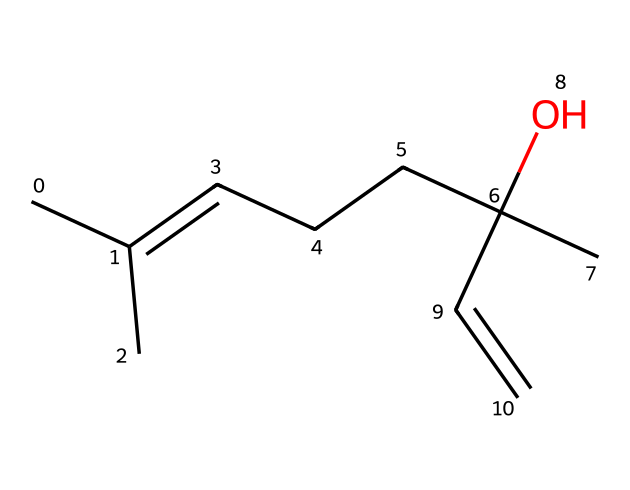What is the common name of this compound? This compound is identified as linalool, which is a well-known terpene commonly found in lavender. The structure reflects common identifying features of linalool.
Answer: linalool How many carbon atoms are present in this structure? By counting the carbon atoms (C) in the SMILES representation, each distinct carbon in the chain counts toward the total. There are ten carbon atoms total in this molecule.
Answer: ten What functional group is represented in this structure? The presence of the hydroxyl group (–OH), indicated by the oxygen atom connected to a carbon, identifies it as an alcohol functional group.
Answer: alcohol Is this compound classified as a saturated or unsaturated hydrocarbon? The presence of double bonds (C=C) in the structure indicates that this compound is unsaturated, as saturated hydrocarbons do not contain double bonds.
Answer: unsaturated What type of compound is linalool primarily considered? Linalool is primarily considered a terpene, which is a class of aromatic compounds derived from plant sources, characterized by their multitude of structural variations.
Answer: terpene Which characteristic of linalool contributes to its fragrance? The presence of the specific arrangement of double bonds and functional groups in the structure give linalool its characteristic floral scent. This floral structure is a typical feature of many terpenes.
Answer: floral scent 